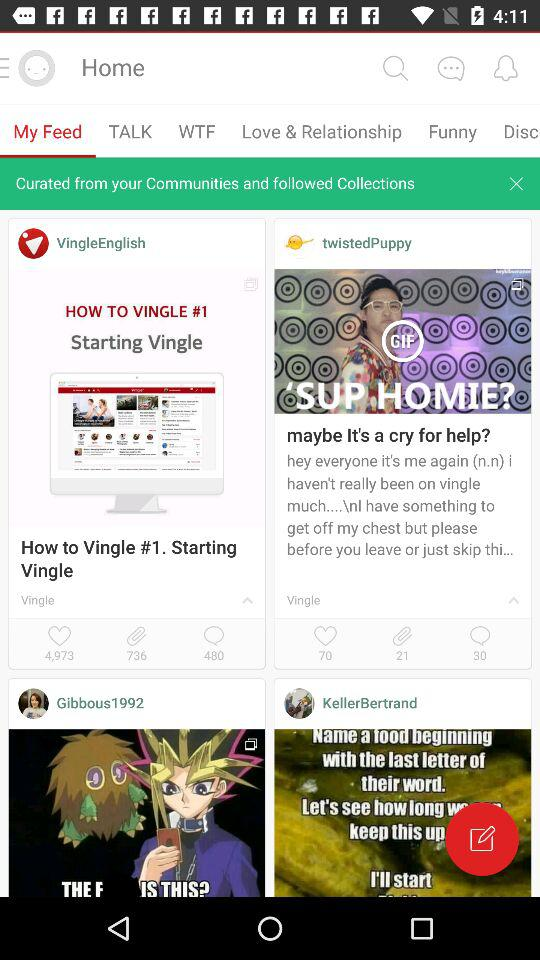How many likes are there on "VingleEnglish"? There are 4973 likes on "VingleEnglish". 